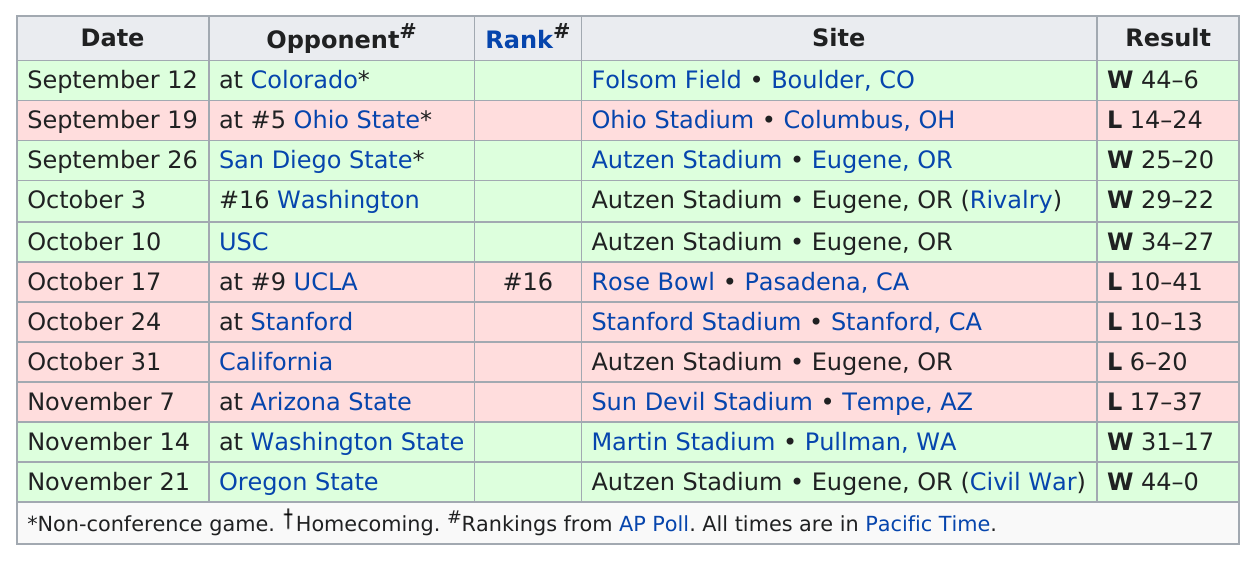Identify some key points in this picture. The University of Oregon Ducks football team played in the Rose Bowl during the 1987 season. Six wins are recorded for the season, The results of the game on November 14 were either above or below the results of the game on October 17. The answer is above. On September 12, the most successful game date for the team was held, other than November 21. The team won two games while not playing at home. 